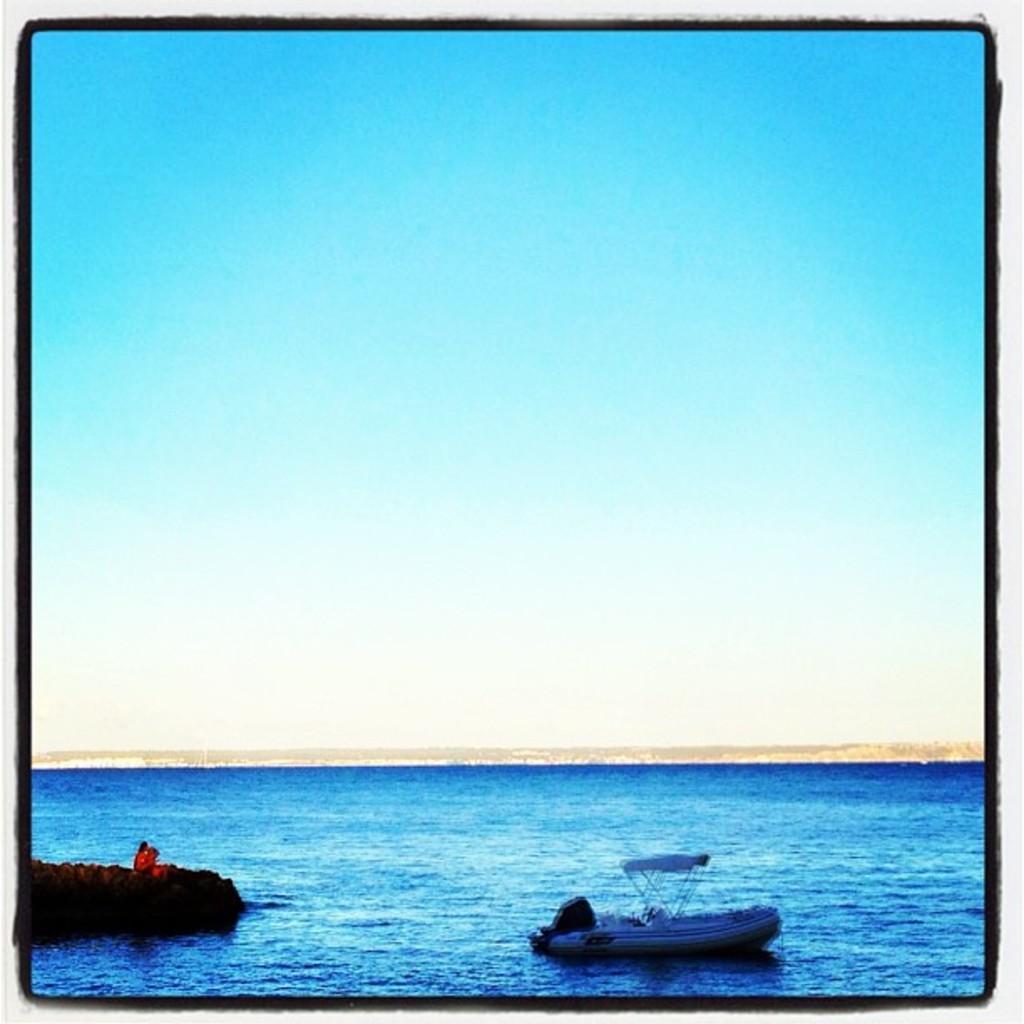Describe this image in one or two sentences. At the bottom I can see boats in the water. On the top I can see the blue sky. This image is taken may be in the ocean. 